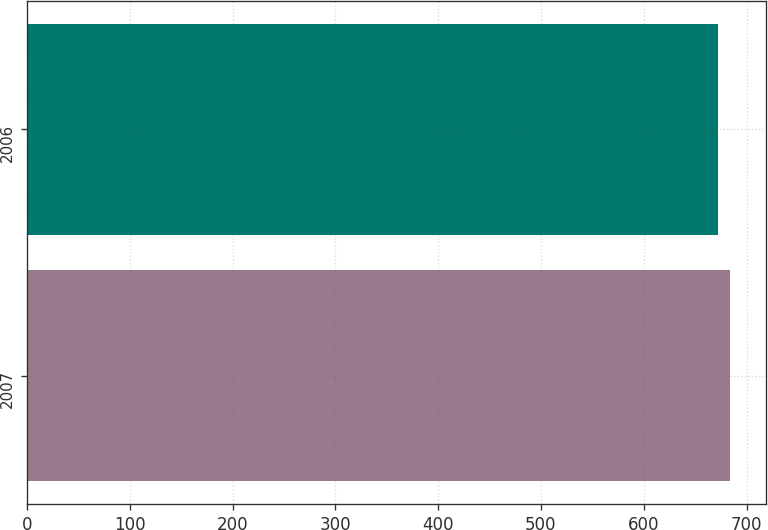<chart> <loc_0><loc_0><loc_500><loc_500><bar_chart><fcel>2007<fcel>2006<nl><fcel>684.3<fcel>672.6<nl></chart> 